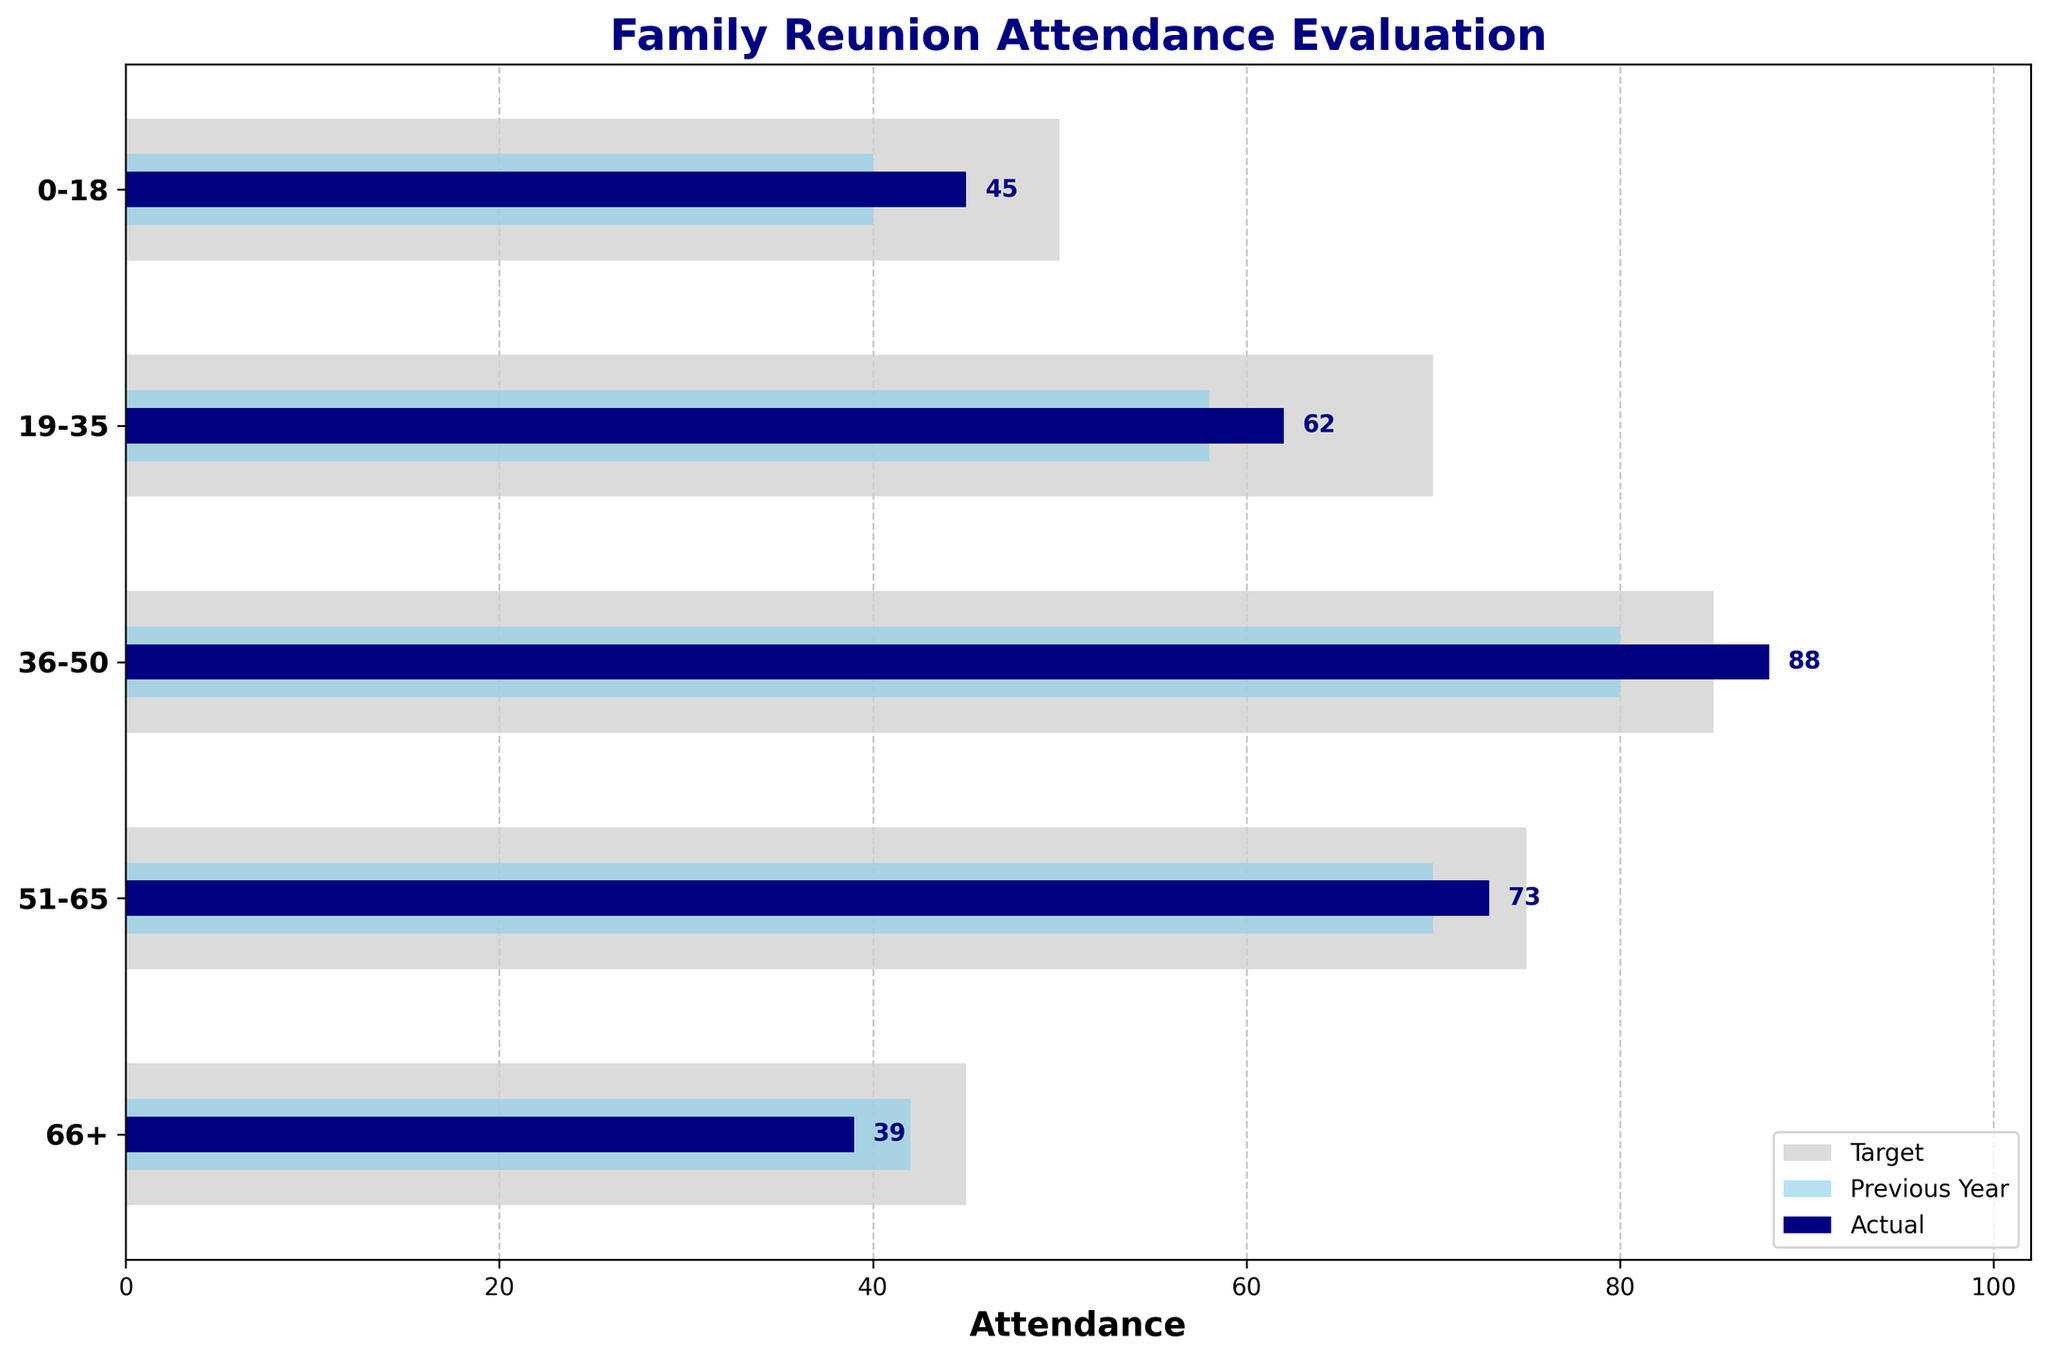How does actual attendance for age group 36-50 compare to its target? The actual attendance for the age group 36-50 is 88, while the target attendance is 85. The actual attendance exceeds the target by 3.
Answer: Actual exceeds target by 3 What is the trend in previous year attendance compared to actual attendance for age group 19-35? The previous year attendance for the age group 19-35 is 58, while the actual attendance is 62. The actual attendance is higher than the previous year by 4.
Answer: Higher by 4 Which age group has the lowest actual attendance? The age group that has the lowest actual attendance is 66+, with 39 attendees.
Answer: 66+ What is the largest difference between actual attendance and previous year attendance? By comparing all age groups, the largest difference between actual attendance and previous year attendance is for age group 36-50, which has an increase from 80 to 88, a difference of 8.
Answer: Difference of 8 How does the actual attendance for the youngest age group (0-18) compare to its target attendance? The actual attendance for the youngest age group (0-18) is 45, while the target attendance is 50. The actual attendance is below the target by 5.
Answer: Below by 5 What is the difference between the actual attendance and previous year attendance for the age group 51-65? The actual attendance for the age group 51-65 is 73, and the previous year attendance was 70. The difference is 3 more attendees this year.
Answer: Difference of 3 Which age group achieved its target attendance the closest? The age group 36-50 has the closest actual attendance to its target with only a difference of 3 (actual: 88, target: 85).
Answer: Age group 36-50 Calculate the average actual attendance across all age groups. The actual attendance values are 45, 62, 88, 73, and 39. The sum is 307, and there are 5 age groups. The average is 307 / 5 = 61.4.
Answer: 61.4 Which age group had the largest increase in attendance from the previous year to the actual attendance? Comparing the differences between actual and previous year for each age group: 0-18 (+5), 19-35 (+4), 36-50 (+8), 51-65 (+3), 66+ (-3), the age group 36-50 had the largest increase of +8.
Answer: Age group 36-50 What is the total target attendance summed across all age groups? The target attendance values are 50, 70, 85, 75, and 45. The sum is 50 + 70 + 85 + 75 + 45 = 325.
Answer: 325 